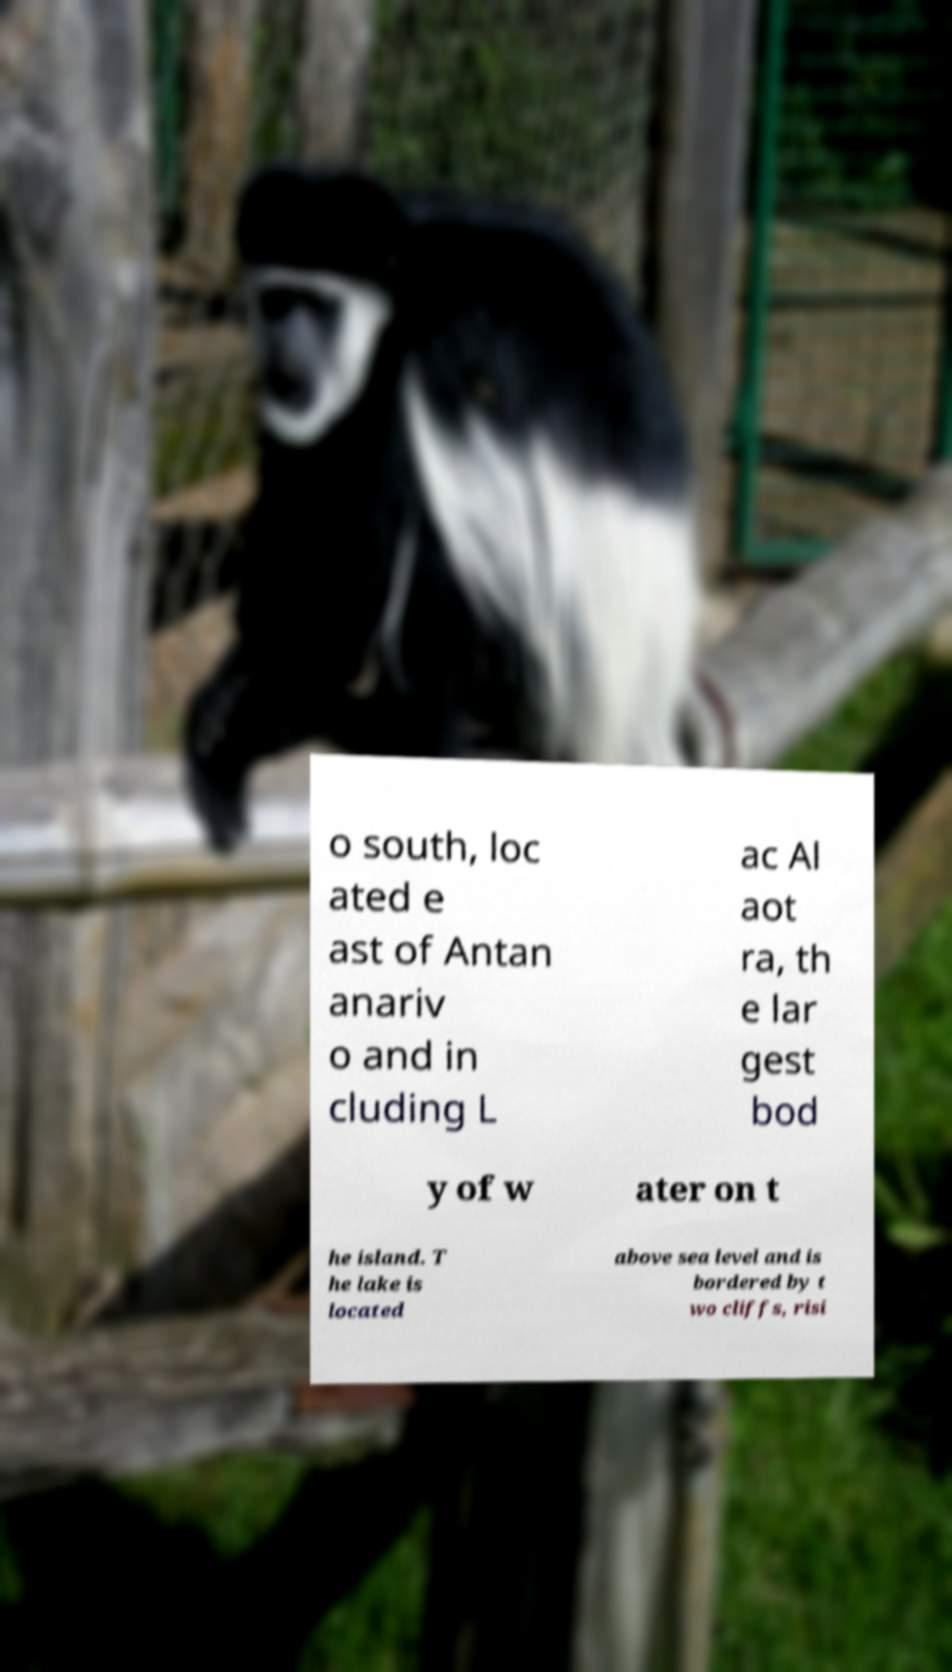For documentation purposes, I need the text within this image transcribed. Could you provide that? o south, loc ated e ast of Antan anariv o and in cluding L ac Al aot ra, th e lar gest bod y of w ater on t he island. T he lake is located above sea level and is bordered by t wo cliffs, risi 